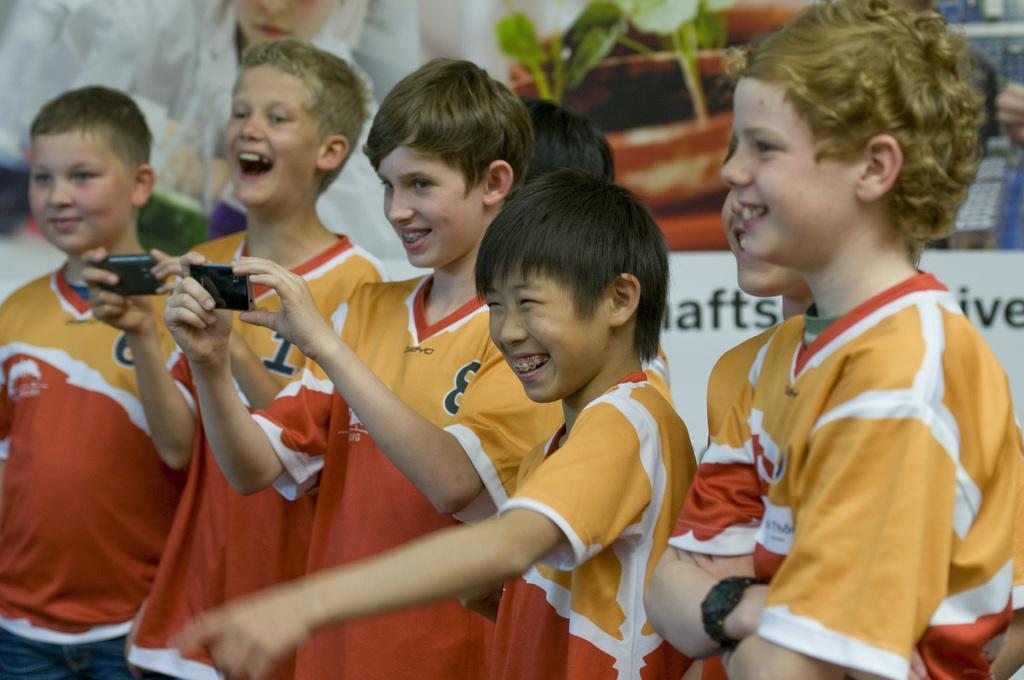<image>
Render a clear and concise summary of the photo. Boy wearing a shirt with the number 8 holding his phone. 